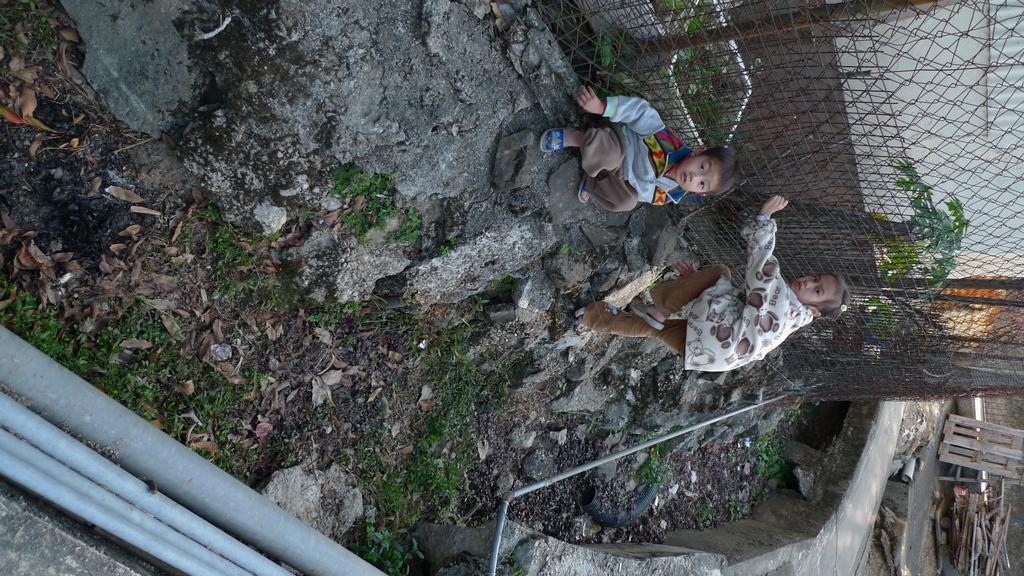How would you summarize this image in a sentence or two? In this image I can see two children on the right side of this image. I can see fencing and woods. I can also see few pipes on the left bottom side of this image. 